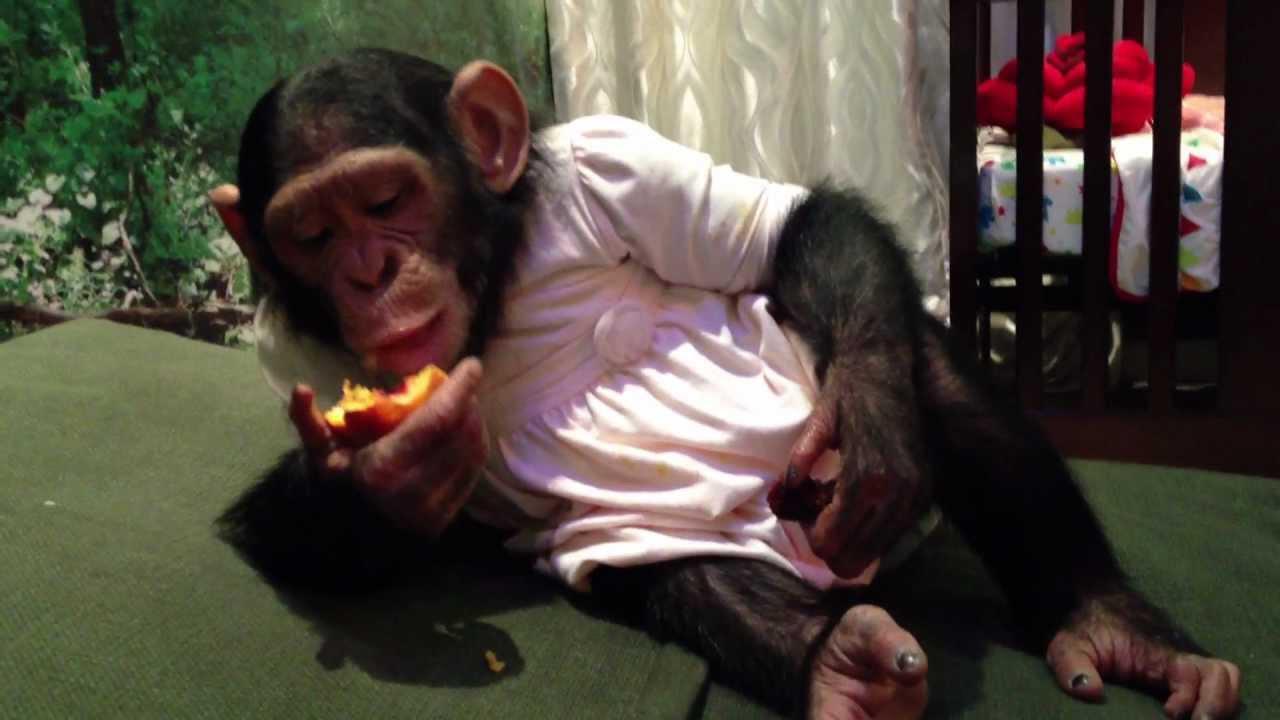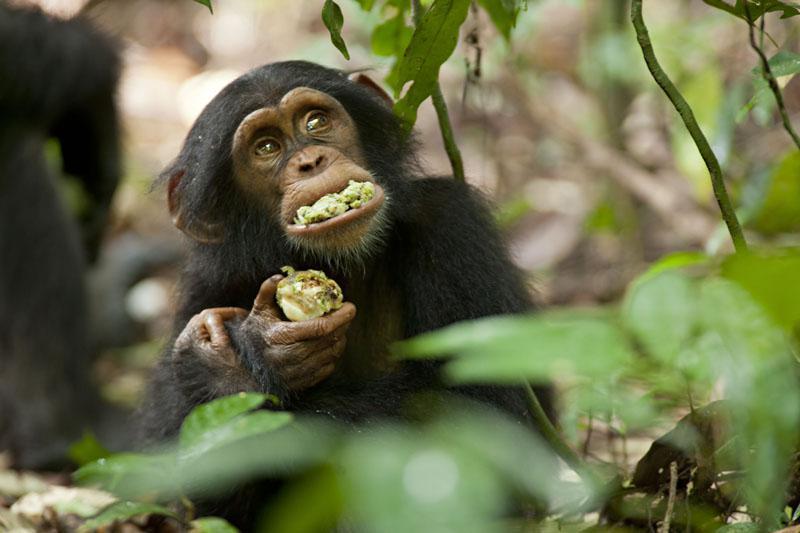The first image is the image on the left, the second image is the image on the right. Assess this claim about the two images: "There is green food in the mouth of the monkey in the image on the right.". Correct or not? Answer yes or no. Yes. The first image is the image on the left, the second image is the image on the right. Considering the images on both sides, is "There is no more than 4 chimpanzees." valid? Answer yes or no. Yes. 